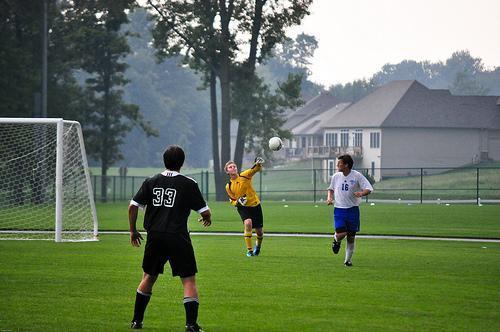How many people are in this photo?
Give a very brief answer. 3. How many soccer balls are visible?
Give a very brief answer. 1. How many boys are playing soccer?
Give a very brief answer. 3. How many men are wearing yellow jerseys?
Give a very brief answer. 1. How many men are wearing a white jersey?
Give a very brief answer. 1. 